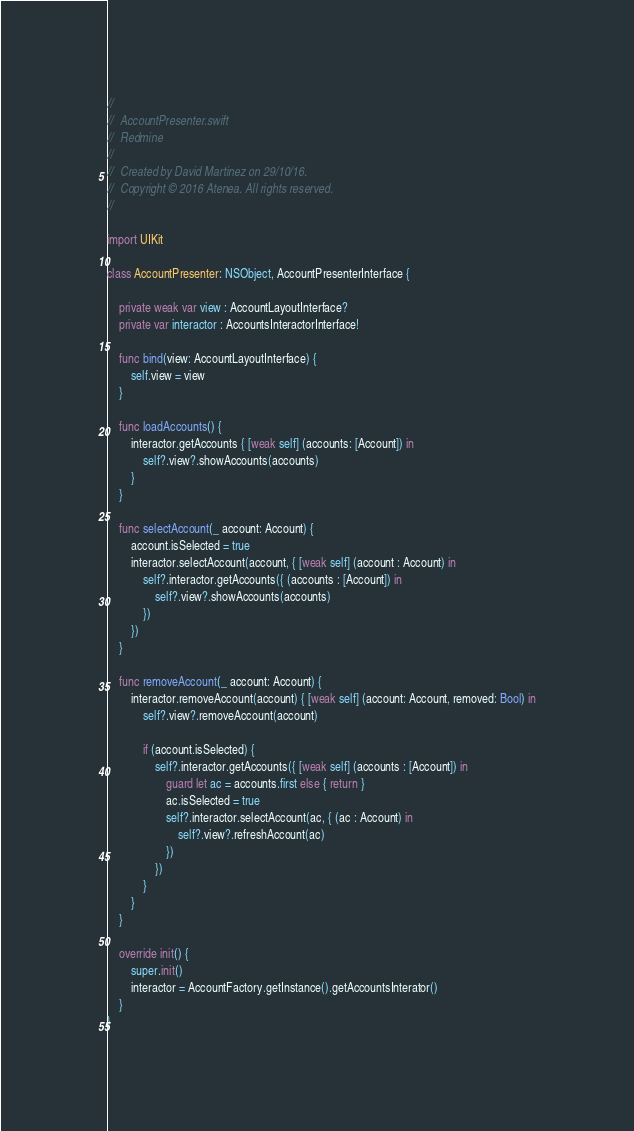Convert code to text. <code><loc_0><loc_0><loc_500><loc_500><_Swift_>//
//  AccountPresenter.swift
//  Redmine
//
//  Created by David Martinez on 29/10/16.
//  Copyright © 2016 Atenea. All rights reserved.
//

import UIKit

class AccountPresenter: NSObject, AccountPresenterInterface {

    private weak var view : AccountLayoutInterface?
    private var interactor : AccountsInteractorInterface!
    
    func bind(view: AccountLayoutInterface) {
        self.view = view
    }
    
    func loadAccounts() {
        interactor.getAccounts { [weak self] (accounts: [Account]) in
            self?.view?.showAccounts(accounts)
        }
    }
    
    func selectAccount(_ account: Account) {
        account.isSelected = true
        interactor.selectAccount(account, { [weak self] (account : Account) in
            self?.interactor.getAccounts({ (accounts : [Account]) in
                self?.view?.showAccounts(accounts)
            })
        })
    }
    
    func removeAccount(_ account: Account) {
        interactor.removeAccount(account) { [weak self] (account: Account, removed: Bool) in
            self?.view?.removeAccount(account)
            
            if (account.isSelected) {
                self?.interactor.getAccounts({ [weak self] (accounts : [Account]) in
                    guard let ac = accounts.first else { return }
                    ac.isSelected = true
                    self?.interactor.selectAccount(ac, { (ac : Account) in
                        self?.view?.refreshAccount(ac)
                    })
                })
            }
        }
    }
    
    override init() {
        super.init()
        interactor = AccountFactory.getInstance().getAccountsInterator()
    }
}
</code> 